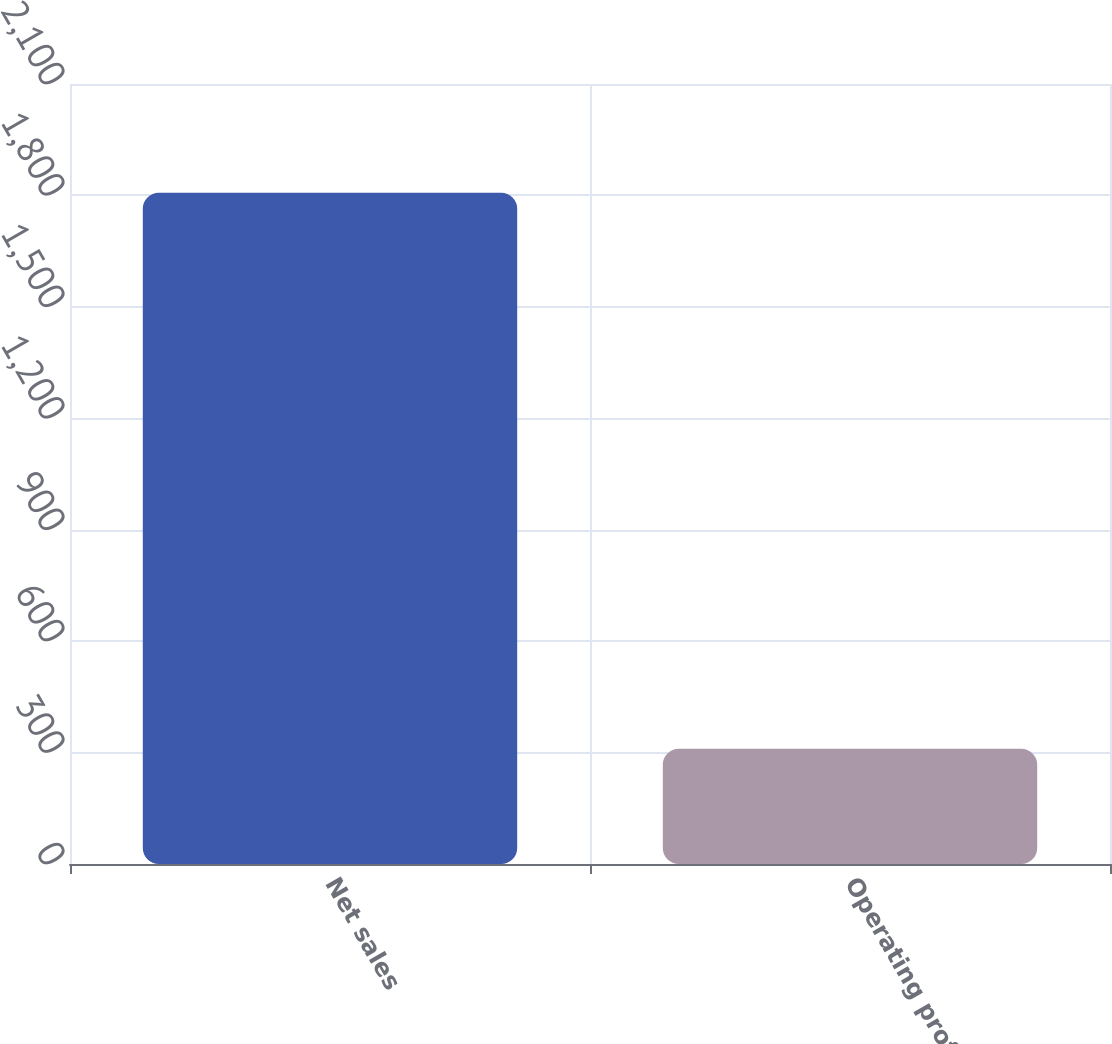Convert chart to OTSL. <chart><loc_0><loc_0><loc_500><loc_500><bar_chart><fcel>Net sales<fcel>Operating profit<nl><fcel>1807<fcel>310<nl></chart> 